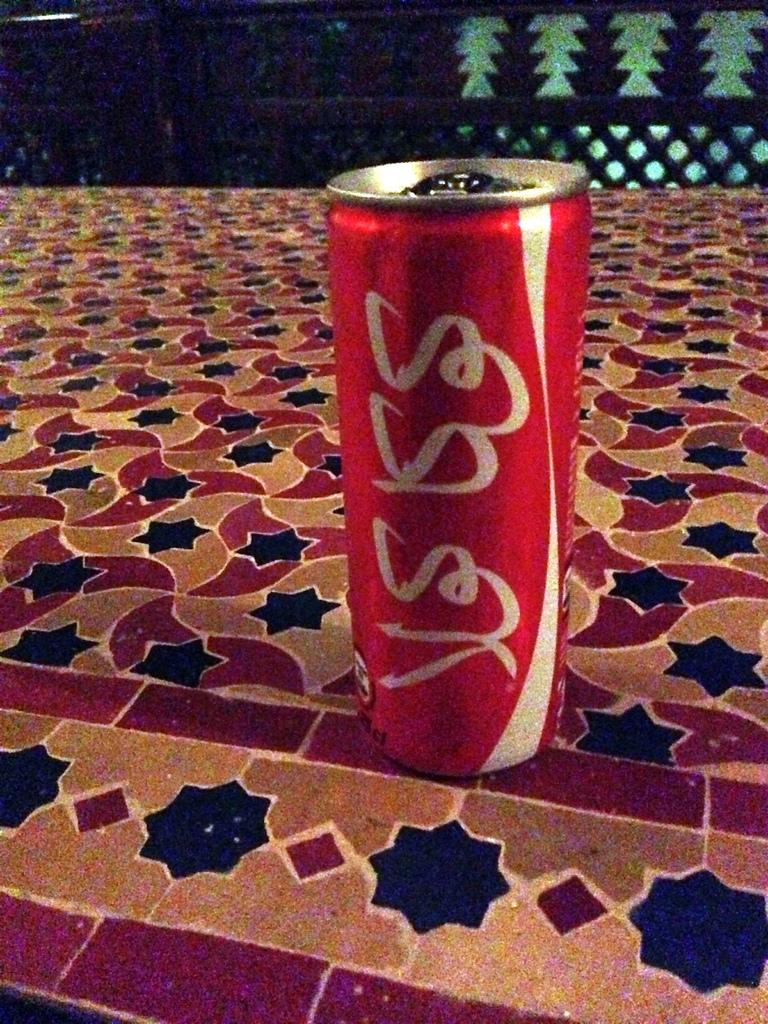What brand of soda is this?
Your response must be concise. Unanswerable. 